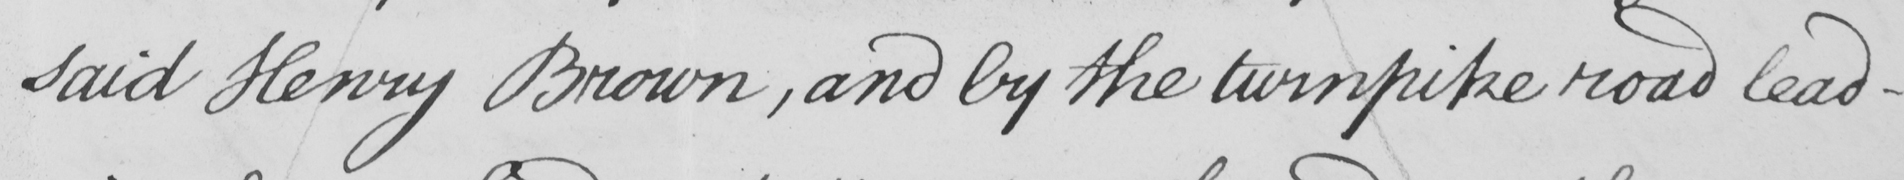What does this handwritten line say? said Henry Brown , and by the turnpike road lead- 